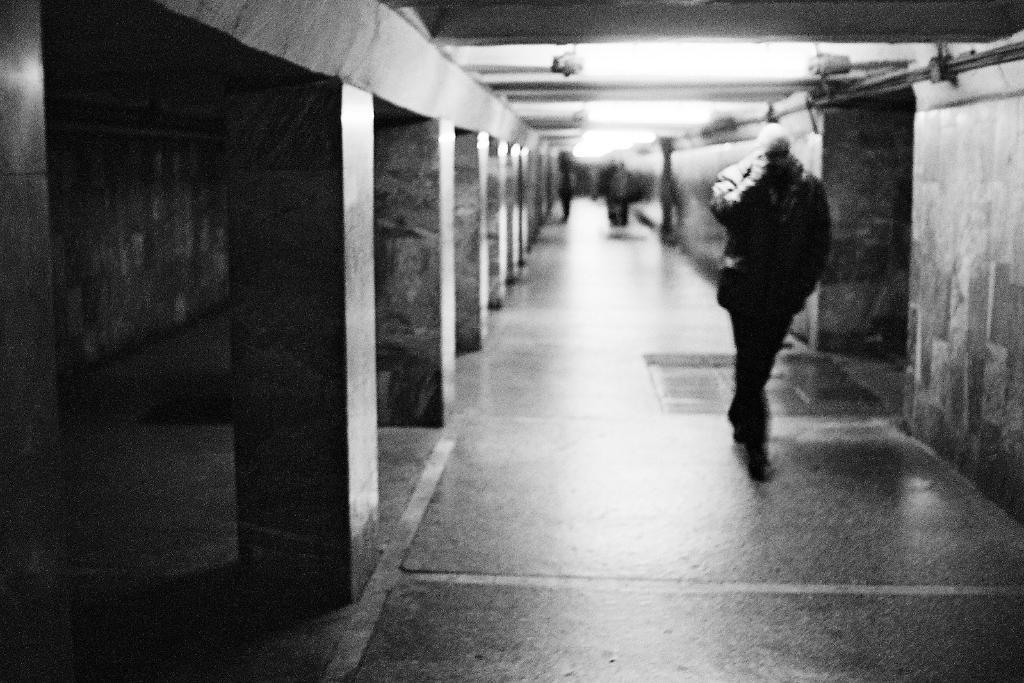How would you summarize this image in a sentence or two? In this image we can see people and there are pillars. In the background there is a wall. At the top there are lights. 